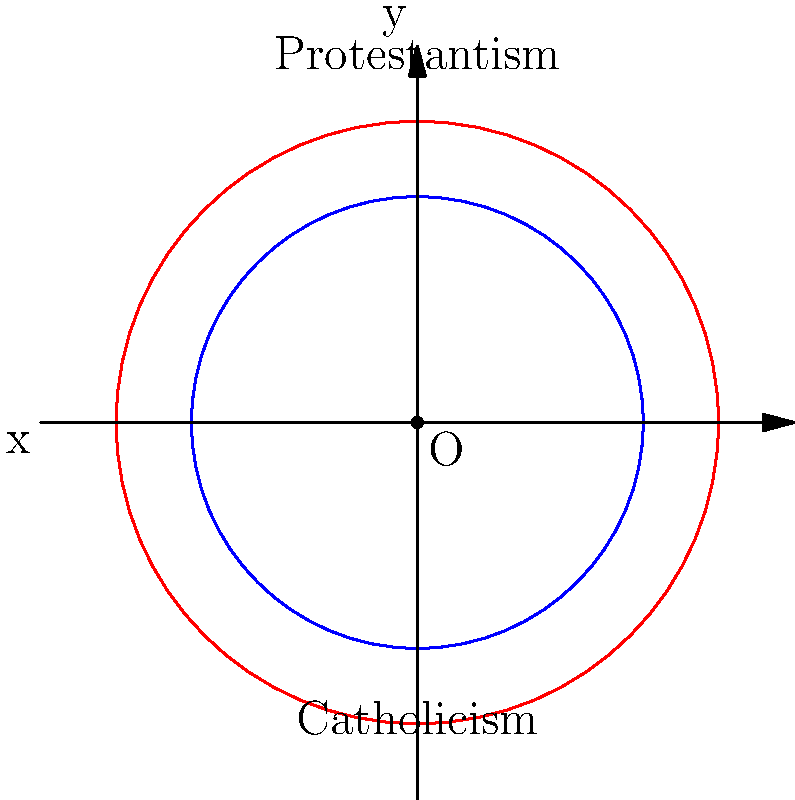On a coordinate map representing religious spheres of influence in 16th century Europe, two circles centered at the origin (0,0) represent the spread of Catholicism and Protestantism. The circle representing Catholicism has a radius of 3 units, while the circle for Protestantism has a radius of 4 units. Calculate the area of overlap between these two religious spheres. Round your answer to two decimal places. To solve this problem, we'll follow these steps:

1) The area of overlap between two circles is given by the formula:

   $A = 2r_1^2 \arccos(\frac{d}{2r_1}) + 2r_2^2 \arccos(\frac{d}{2r_2}) - d\sqrt{r_1^2 - \frac{d^2}{4}} - d\sqrt{r_2^2 - \frac{d^2}{4}}$

   Where $r_1$ and $r_2$ are the radii of the circles, and $d$ is the distance between their centers.

2) In this case, $r_1 = 3$, $r_2 = 4$, and $d = 0$ (since both circles are centered at the origin).

3) Substituting these values into the formula:

   $A = 2(3^2) \arccos(\frac{0}{2(3)}) + 2(4^2) \arccos(\frac{0}{2(4)}) - 0\sqrt{3^2 - \frac{0^2}{4}} - 0\sqrt{4^2 - \frac{0^2}{4}}$

4) Simplify:

   $A = 18 \arccos(0) + 32 \arccos(0) - 0 - 0$

5) $\arccos(0) = \frac{\pi}{2}$, so:

   $A = 18 (\frac{\pi}{2}) + 32 (\frac{\pi}{2})$

6) Simplify:

   $A = 9\pi + 16\pi = 25\pi$

7) Calculate and round to two decimal places:

   $A \approx 78.54$

Therefore, the area of overlap between the Catholic and Protestant spheres of influence is approximately 78.54 square units.
Answer: 78.54 square units 